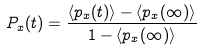<formula> <loc_0><loc_0><loc_500><loc_500>P _ { x } ( t ) = \frac { \langle p _ { x } ( t ) \rangle - \langle p _ { x } ( \infty ) \rangle } { 1 - \langle p _ { x } ( \infty ) \rangle }</formula> 